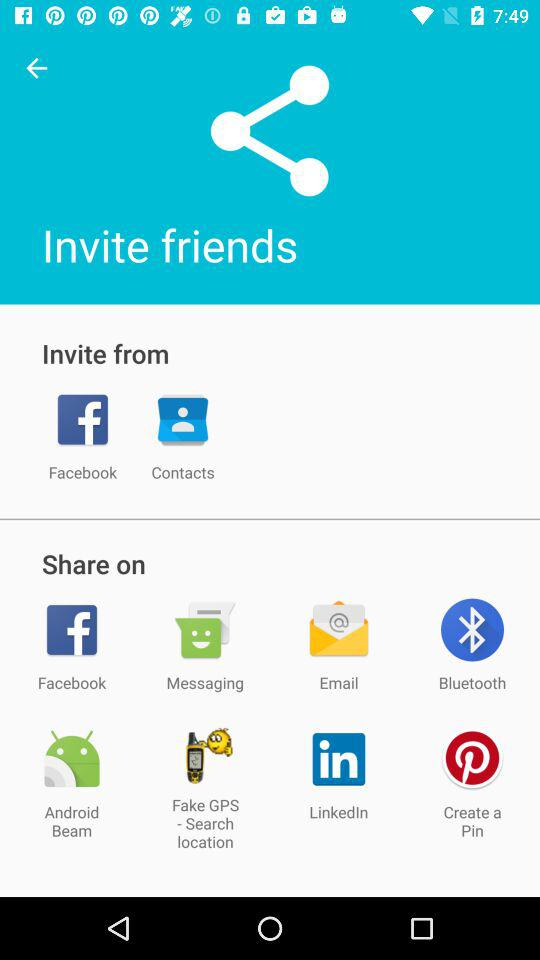Through what applications can a user share? A user can share it through "Facebook", "Messaging", "Email", "Bluetooth", "Android Beam", "Fake GPS - Search location", "LinkedIn", and "Create a Pin". 